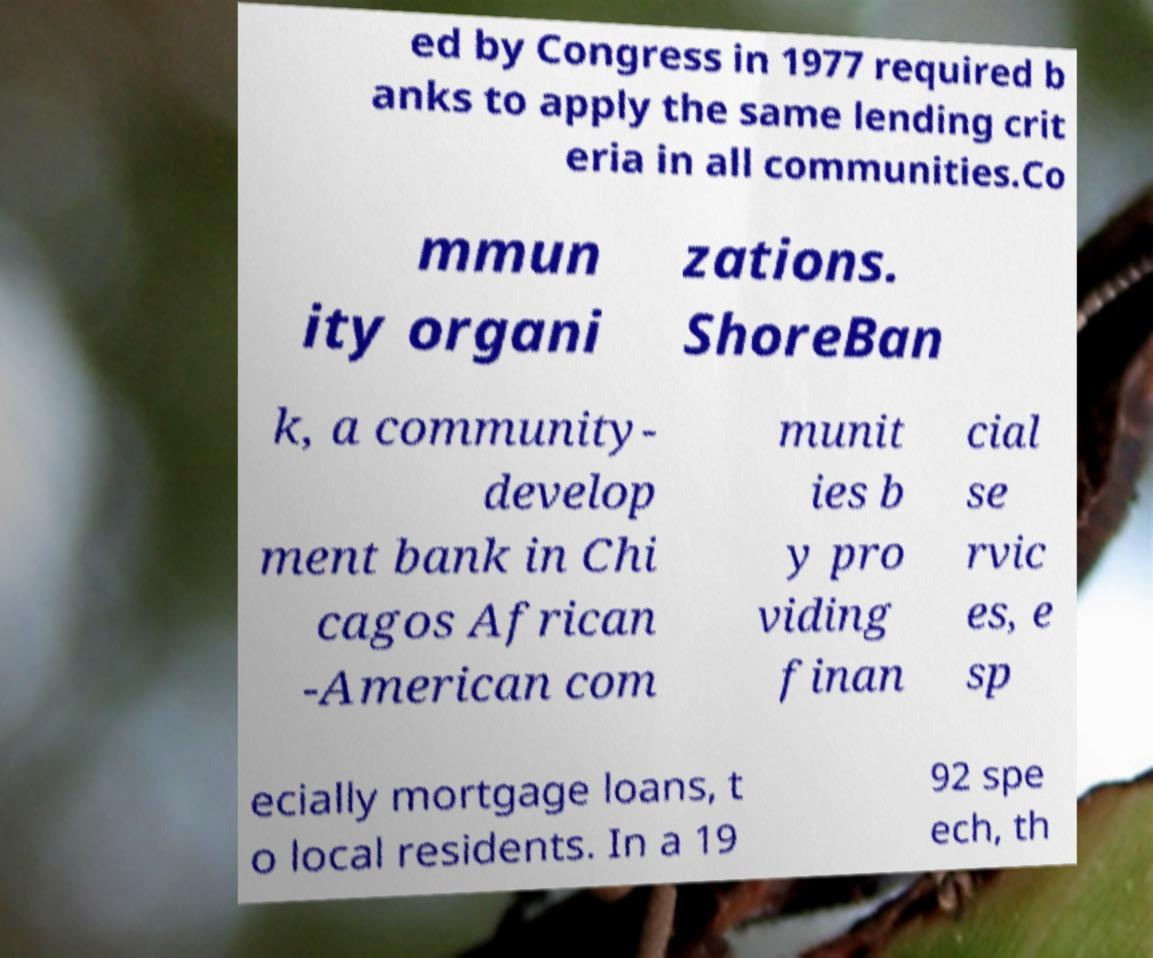What messages or text are displayed in this image? I need them in a readable, typed format. ed by Congress in 1977 required b anks to apply the same lending crit eria in all communities.Co mmun ity organi zations. ShoreBan k, a community- develop ment bank in Chi cagos African -American com munit ies b y pro viding finan cial se rvic es, e sp ecially mortgage loans, t o local residents. In a 19 92 spe ech, th 